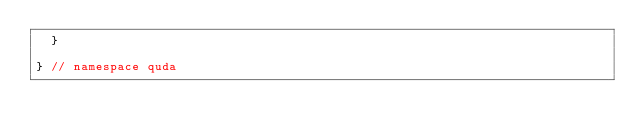Convert code to text. <code><loc_0><loc_0><loc_500><loc_500><_Cuda_>  }

} // namespace quda
</code> 